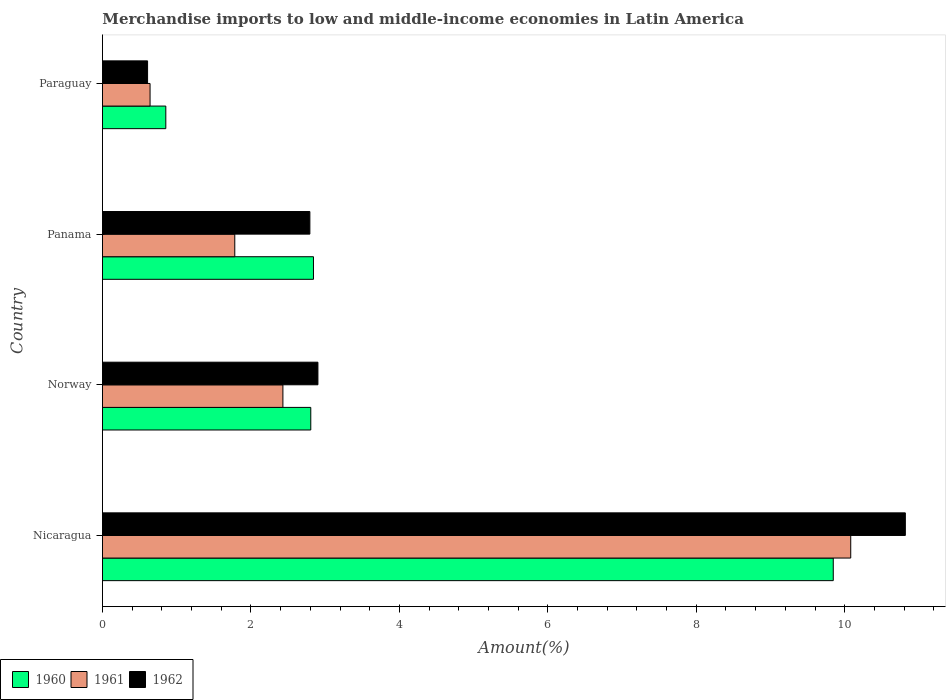Are the number of bars on each tick of the Y-axis equal?
Ensure brevity in your answer.  Yes. What is the label of the 4th group of bars from the top?
Provide a succinct answer. Nicaragua. What is the percentage of amount earned from merchandise imports in 1961 in Norway?
Make the answer very short. 2.43. Across all countries, what is the maximum percentage of amount earned from merchandise imports in 1961?
Offer a terse response. 10.08. Across all countries, what is the minimum percentage of amount earned from merchandise imports in 1961?
Ensure brevity in your answer.  0.64. In which country was the percentage of amount earned from merchandise imports in 1961 maximum?
Your answer should be compact. Nicaragua. In which country was the percentage of amount earned from merchandise imports in 1960 minimum?
Your answer should be compact. Paraguay. What is the total percentage of amount earned from merchandise imports in 1961 in the graph?
Offer a very short reply. 14.94. What is the difference between the percentage of amount earned from merchandise imports in 1960 in Panama and that in Paraguay?
Your answer should be very brief. 1.99. What is the difference between the percentage of amount earned from merchandise imports in 1960 in Norway and the percentage of amount earned from merchandise imports in 1962 in Paraguay?
Offer a terse response. 2.2. What is the average percentage of amount earned from merchandise imports in 1962 per country?
Offer a very short reply. 4.28. What is the difference between the percentage of amount earned from merchandise imports in 1960 and percentage of amount earned from merchandise imports in 1961 in Panama?
Ensure brevity in your answer.  1.06. What is the ratio of the percentage of amount earned from merchandise imports in 1960 in Nicaragua to that in Paraguay?
Offer a terse response. 11.54. Is the percentage of amount earned from merchandise imports in 1961 in Nicaragua less than that in Panama?
Ensure brevity in your answer.  No. Is the difference between the percentage of amount earned from merchandise imports in 1960 in Panama and Paraguay greater than the difference between the percentage of amount earned from merchandise imports in 1961 in Panama and Paraguay?
Offer a very short reply. Yes. What is the difference between the highest and the second highest percentage of amount earned from merchandise imports in 1962?
Offer a terse response. 7.91. What is the difference between the highest and the lowest percentage of amount earned from merchandise imports in 1961?
Your answer should be compact. 9.44. What does the 2nd bar from the top in Panama represents?
Your answer should be compact. 1961. Is it the case that in every country, the sum of the percentage of amount earned from merchandise imports in 1961 and percentage of amount earned from merchandise imports in 1962 is greater than the percentage of amount earned from merchandise imports in 1960?
Provide a succinct answer. Yes. Are all the bars in the graph horizontal?
Provide a short and direct response. Yes. What is the difference between two consecutive major ticks on the X-axis?
Your answer should be compact. 2. Are the values on the major ticks of X-axis written in scientific E-notation?
Offer a terse response. No. Where does the legend appear in the graph?
Ensure brevity in your answer.  Bottom left. How many legend labels are there?
Provide a succinct answer. 3. How are the legend labels stacked?
Keep it short and to the point. Horizontal. What is the title of the graph?
Offer a very short reply. Merchandise imports to low and middle-income economies in Latin America. What is the label or title of the X-axis?
Your answer should be very brief. Amount(%). What is the label or title of the Y-axis?
Your answer should be very brief. Country. What is the Amount(%) of 1960 in Nicaragua?
Your answer should be very brief. 9.85. What is the Amount(%) in 1961 in Nicaragua?
Keep it short and to the point. 10.08. What is the Amount(%) in 1962 in Nicaragua?
Your answer should be very brief. 10.82. What is the Amount(%) of 1960 in Norway?
Keep it short and to the point. 2.81. What is the Amount(%) of 1961 in Norway?
Give a very brief answer. 2.43. What is the Amount(%) in 1962 in Norway?
Make the answer very short. 2.9. What is the Amount(%) in 1960 in Panama?
Keep it short and to the point. 2.84. What is the Amount(%) in 1961 in Panama?
Provide a succinct answer. 1.78. What is the Amount(%) in 1962 in Panama?
Your answer should be compact. 2.79. What is the Amount(%) of 1960 in Paraguay?
Ensure brevity in your answer.  0.85. What is the Amount(%) in 1961 in Paraguay?
Your answer should be very brief. 0.64. What is the Amount(%) of 1962 in Paraguay?
Offer a very short reply. 0.61. Across all countries, what is the maximum Amount(%) of 1960?
Keep it short and to the point. 9.85. Across all countries, what is the maximum Amount(%) in 1961?
Give a very brief answer. 10.08. Across all countries, what is the maximum Amount(%) in 1962?
Provide a short and direct response. 10.82. Across all countries, what is the minimum Amount(%) of 1960?
Offer a very short reply. 0.85. Across all countries, what is the minimum Amount(%) in 1961?
Your response must be concise. 0.64. Across all countries, what is the minimum Amount(%) of 1962?
Your response must be concise. 0.61. What is the total Amount(%) in 1960 in the graph?
Give a very brief answer. 16.35. What is the total Amount(%) of 1961 in the graph?
Keep it short and to the point. 14.94. What is the total Amount(%) in 1962 in the graph?
Keep it short and to the point. 17.12. What is the difference between the Amount(%) of 1960 in Nicaragua and that in Norway?
Your answer should be very brief. 7.04. What is the difference between the Amount(%) of 1961 in Nicaragua and that in Norway?
Make the answer very short. 7.65. What is the difference between the Amount(%) in 1962 in Nicaragua and that in Norway?
Offer a terse response. 7.91. What is the difference between the Amount(%) of 1960 in Nicaragua and that in Panama?
Provide a short and direct response. 7. What is the difference between the Amount(%) in 1961 in Nicaragua and that in Panama?
Keep it short and to the point. 8.3. What is the difference between the Amount(%) in 1962 in Nicaragua and that in Panama?
Provide a short and direct response. 8.02. What is the difference between the Amount(%) in 1960 in Nicaragua and that in Paraguay?
Offer a very short reply. 8.99. What is the difference between the Amount(%) in 1961 in Nicaragua and that in Paraguay?
Provide a short and direct response. 9.44. What is the difference between the Amount(%) of 1962 in Nicaragua and that in Paraguay?
Provide a succinct answer. 10.21. What is the difference between the Amount(%) of 1960 in Norway and that in Panama?
Offer a very short reply. -0.04. What is the difference between the Amount(%) of 1961 in Norway and that in Panama?
Ensure brevity in your answer.  0.65. What is the difference between the Amount(%) of 1962 in Norway and that in Panama?
Offer a very short reply. 0.11. What is the difference between the Amount(%) in 1960 in Norway and that in Paraguay?
Ensure brevity in your answer.  1.95. What is the difference between the Amount(%) of 1961 in Norway and that in Paraguay?
Provide a short and direct response. 1.79. What is the difference between the Amount(%) in 1962 in Norway and that in Paraguay?
Give a very brief answer. 2.29. What is the difference between the Amount(%) of 1960 in Panama and that in Paraguay?
Your answer should be compact. 1.99. What is the difference between the Amount(%) of 1961 in Panama and that in Paraguay?
Provide a short and direct response. 1.14. What is the difference between the Amount(%) in 1962 in Panama and that in Paraguay?
Ensure brevity in your answer.  2.19. What is the difference between the Amount(%) of 1960 in Nicaragua and the Amount(%) of 1961 in Norway?
Your answer should be very brief. 7.41. What is the difference between the Amount(%) in 1960 in Nicaragua and the Amount(%) in 1962 in Norway?
Keep it short and to the point. 6.94. What is the difference between the Amount(%) of 1961 in Nicaragua and the Amount(%) of 1962 in Norway?
Your answer should be compact. 7.18. What is the difference between the Amount(%) of 1960 in Nicaragua and the Amount(%) of 1961 in Panama?
Give a very brief answer. 8.06. What is the difference between the Amount(%) in 1960 in Nicaragua and the Amount(%) in 1962 in Panama?
Your response must be concise. 7.05. What is the difference between the Amount(%) of 1961 in Nicaragua and the Amount(%) of 1962 in Panama?
Your response must be concise. 7.29. What is the difference between the Amount(%) of 1960 in Nicaragua and the Amount(%) of 1961 in Paraguay?
Provide a short and direct response. 9.2. What is the difference between the Amount(%) of 1960 in Nicaragua and the Amount(%) of 1962 in Paraguay?
Ensure brevity in your answer.  9.24. What is the difference between the Amount(%) in 1961 in Nicaragua and the Amount(%) in 1962 in Paraguay?
Offer a very short reply. 9.47. What is the difference between the Amount(%) in 1960 in Norway and the Amount(%) in 1961 in Panama?
Your answer should be very brief. 1.02. What is the difference between the Amount(%) of 1960 in Norway and the Amount(%) of 1962 in Panama?
Provide a succinct answer. 0.01. What is the difference between the Amount(%) of 1961 in Norway and the Amount(%) of 1962 in Panama?
Provide a short and direct response. -0.36. What is the difference between the Amount(%) of 1960 in Norway and the Amount(%) of 1961 in Paraguay?
Your answer should be very brief. 2.17. What is the difference between the Amount(%) of 1960 in Norway and the Amount(%) of 1962 in Paraguay?
Keep it short and to the point. 2.2. What is the difference between the Amount(%) in 1961 in Norway and the Amount(%) in 1962 in Paraguay?
Your response must be concise. 1.82. What is the difference between the Amount(%) in 1960 in Panama and the Amount(%) in 1961 in Paraguay?
Your answer should be compact. 2.2. What is the difference between the Amount(%) in 1960 in Panama and the Amount(%) in 1962 in Paraguay?
Your answer should be very brief. 2.23. What is the difference between the Amount(%) of 1961 in Panama and the Amount(%) of 1962 in Paraguay?
Give a very brief answer. 1.17. What is the average Amount(%) of 1960 per country?
Keep it short and to the point. 4.09. What is the average Amount(%) of 1961 per country?
Your response must be concise. 3.73. What is the average Amount(%) of 1962 per country?
Keep it short and to the point. 4.28. What is the difference between the Amount(%) of 1960 and Amount(%) of 1961 in Nicaragua?
Keep it short and to the point. -0.24. What is the difference between the Amount(%) in 1960 and Amount(%) in 1962 in Nicaragua?
Keep it short and to the point. -0.97. What is the difference between the Amount(%) in 1961 and Amount(%) in 1962 in Nicaragua?
Provide a succinct answer. -0.74. What is the difference between the Amount(%) in 1960 and Amount(%) in 1961 in Norway?
Make the answer very short. 0.38. What is the difference between the Amount(%) of 1960 and Amount(%) of 1962 in Norway?
Offer a very short reply. -0.1. What is the difference between the Amount(%) in 1961 and Amount(%) in 1962 in Norway?
Keep it short and to the point. -0.47. What is the difference between the Amount(%) of 1960 and Amount(%) of 1961 in Panama?
Your response must be concise. 1.06. What is the difference between the Amount(%) of 1960 and Amount(%) of 1962 in Panama?
Your response must be concise. 0.05. What is the difference between the Amount(%) of 1961 and Amount(%) of 1962 in Panama?
Ensure brevity in your answer.  -1.01. What is the difference between the Amount(%) in 1960 and Amount(%) in 1961 in Paraguay?
Your answer should be compact. 0.21. What is the difference between the Amount(%) of 1960 and Amount(%) of 1962 in Paraguay?
Keep it short and to the point. 0.25. What is the difference between the Amount(%) in 1961 and Amount(%) in 1962 in Paraguay?
Offer a terse response. 0.03. What is the ratio of the Amount(%) of 1960 in Nicaragua to that in Norway?
Ensure brevity in your answer.  3.51. What is the ratio of the Amount(%) of 1961 in Nicaragua to that in Norway?
Your answer should be compact. 4.15. What is the ratio of the Amount(%) in 1962 in Nicaragua to that in Norway?
Give a very brief answer. 3.73. What is the ratio of the Amount(%) of 1960 in Nicaragua to that in Panama?
Provide a succinct answer. 3.46. What is the ratio of the Amount(%) in 1961 in Nicaragua to that in Panama?
Ensure brevity in your answer.  5.66. What is the ratio of the Amount(%) in 1962 in Nicaragua to that in Panama?
Ensure brevity in your answer.  3.87. What is the ratio of the Amount(%) of 1960 in Nicaragua to that in Paraguay?
Give a very brief answer. 11.54. What is the ratio of the Amount(%) in 1961 in Nicaragua to that in Paraguay?
Keep it short and to the point. 15.72. What is the ratio of the Amount(%) in 1962 in Nicaragua to that in Paraguay?
Ensure brevity in your answer.  17.8. What is the ratio of the Amount(%) of 1960 in Norway to that in Panama?
Your response must be concise. 0.99. What is the ratio of the Amount(%) in 1961 in Norway to that in Panama?
Provide a short and direct response. 1.36. What is the ratio of the Amount(%) in 1962 in Norway to that in Panama?
Provide a succinct answer. 1.04. What is the ratio of the Amount(%) of 1960 in Norway to that in Paraguay?
Your answer should be very brief. 3.29. What is the ratio of the Amount(%) in 1961 in Norway to that in Paraguay?
Make the answer very short. 3.79. What is the ratio of the Amount(%) in 1962 in Norway to that in Paraguay?
Your answer should be very brief. 4.78. What is the ratio of the Amount(%) of 1960 in Panama to that in Paraguay?
Your answer should be compact. 3.33. What is the ratio of the Amount(%) of 1961 in Panama to that in Paraguay?
Your answer should be very brief. 2.78. What is the ratio of the Amount(%) of 1962 in Panama to that in Paraguay?
Make the answer very short. 4.6. What is the difference between the highest and the second highest Amount(%) of 1960?
Keep it short and to the point. 7. What is the difference between the highest and the second highest Amount(%) of 1961?
Make the answer very short. 7.65. What is the difference between the highest and the second highest Amount(%) of 1962?
Offer a terse response. 7.91. What is the difference between the highest and the lowest Amount(%) of 1960?
Provide a succinct answer. 8.99. What is the difference between the highest and the lowest Amount(%) of 1961?
Provide a succinct answer. 9.44. What is the difference between the highest and the lowest Amount(%) of 1962?
Keep it short and to the point. 10.21. 